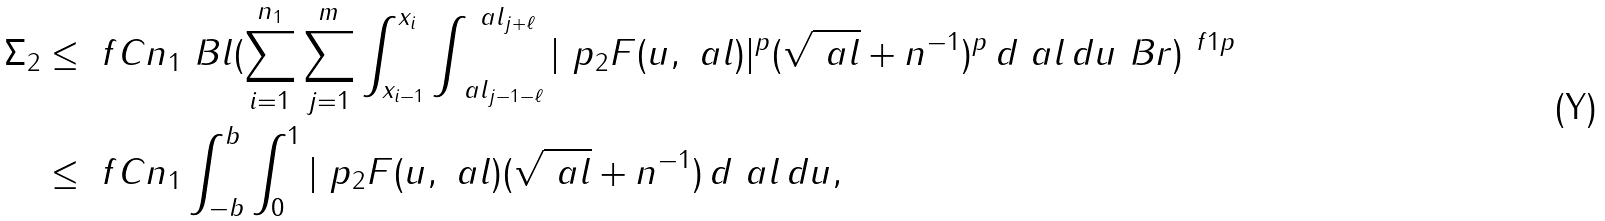Convert formula to latex. <formula><loc_0><loc_0><loc_500><loc_500>\Sigma _ { 2 } & \leq \ f C { n _ { 1 } } \ B l ( \sum _ { i = 1 } ^ { n _ { 1 } } \sum _ { j = 1 } ^ { m } \int _ { x _ { i - 1 } } ^ { x _ { i } } \int _ { \ a l _ { j - 1 - \ell } } ^ { \ a l _ { j + \ell } } | \ p _ { 2 } F ( u , \ a l ) | ^ { p } ( \sqrt { \ a l } + n ^ { - 1 } ) ^ { p } \, d \ a l \, d u \ B r ) ^ { \ f 1 p } \\ & \leq \ f C { n _ { 1 } } \int _ { - b } ^ { b } \int _ { 0 } ^ { 1 } | \ p _ { 2 } F ( u , \ a l ) ( \sqrt { \ a l } + n ^ { - 1 } ) \, d \ a l \, d u ,</formula> 